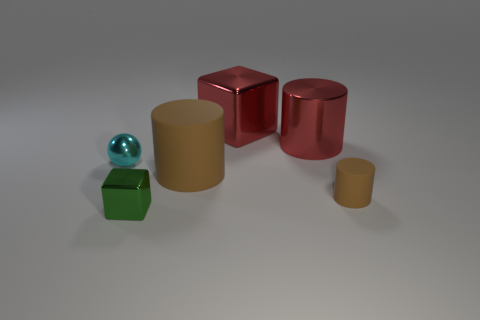There is a rubber thing on the right side of the large shiny cube; is it the same shape as the big brown object?
Keep it short and to the point. Yes. What shape is the rubber thing right of the metallic cylinder?
Offer a terse response. Cylinder. There is a thing that is the same color as the big metal cylinder; what shape is it?
Give a very brief answer. Cube. What number of red things have the same size as the metal cylinder?
Offer a terse response. 1. What is the color of the tiny metal sphere?
Ensure brevity in your answer.  Cyan. Does the small cylinder have the same color as the rubber cylinder that is to the left of the small matte thing?
Your answer should be very brief. Yes. What is the size of the red cube that is the same material as the tiny green thing?
Your answer should be compact. Large. Are there any shiny things of the same color as the big shiny cylinder?
Your answer should be very brief. Yes. What number of objects are either tiny things that are on the left side of the green cube or large cubes?
Keep it short and to the point. 2. Do the large red cylinder and the large cylinder that is in front of the red shiny cylinder have the same material?
Your answer should be compact. No. 